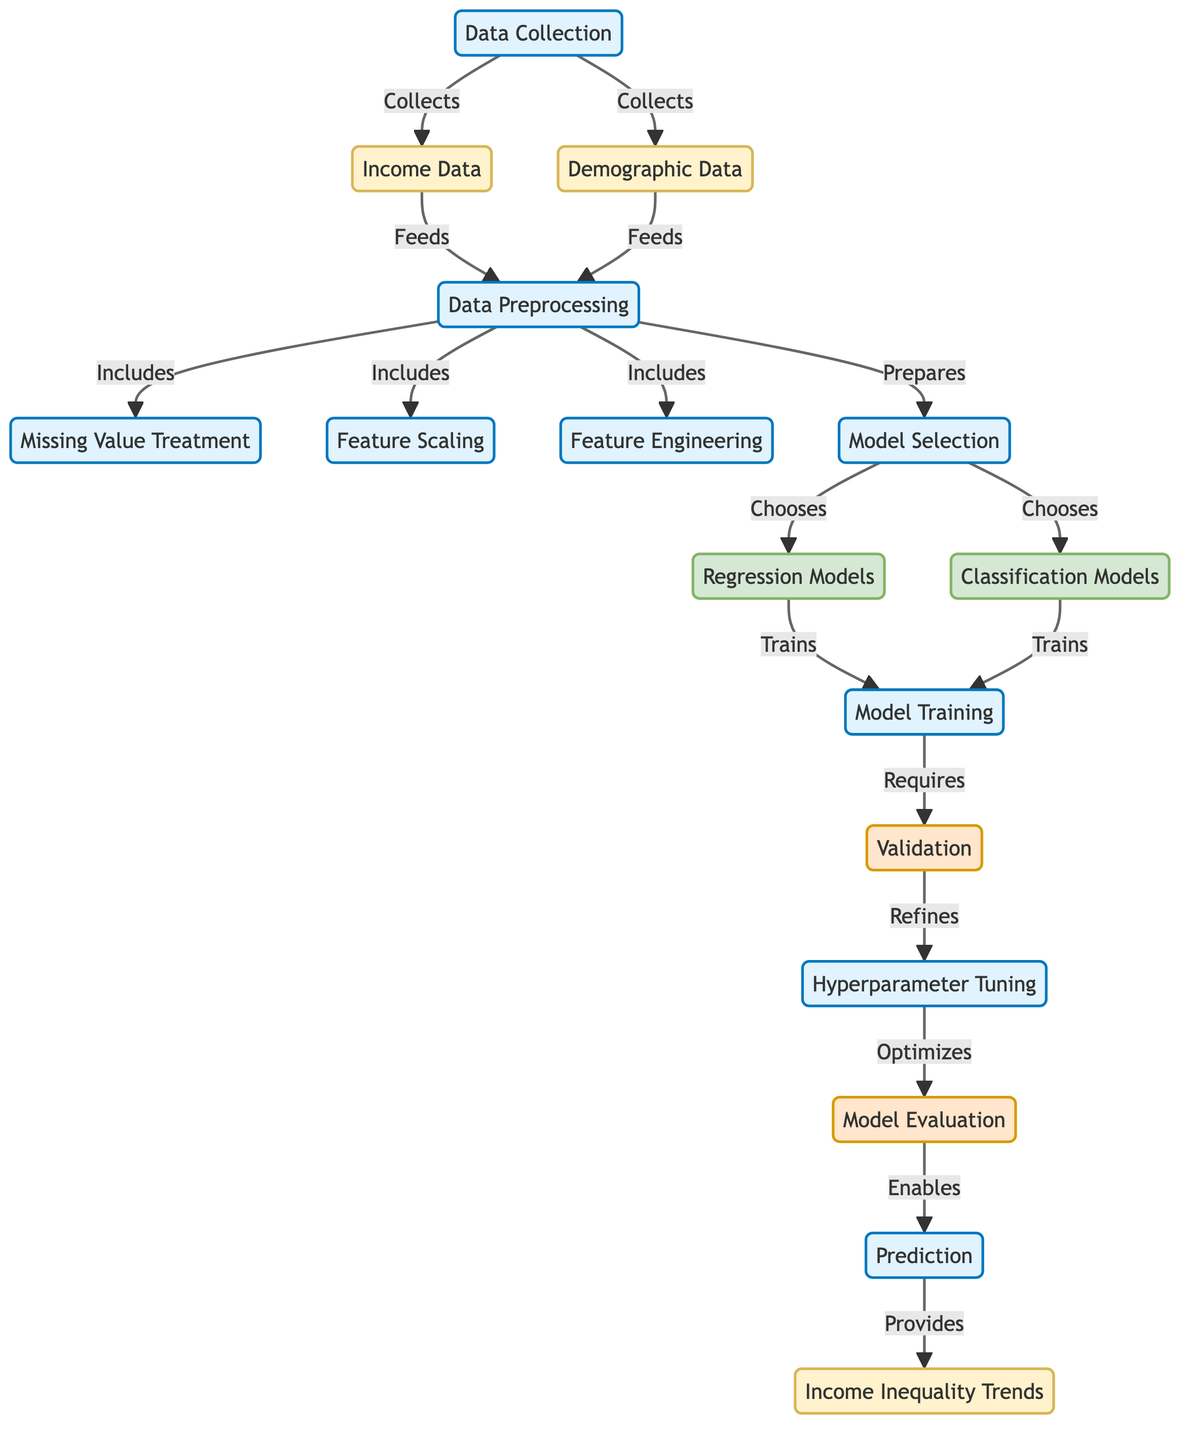What nodes are involved in data collection? The diagram indicates that two nodes are involved in data collection: Income Data and Demographic Data, both of which are collected during the Data Collection process.
Answer: Income Data, Demographic Data What processes come after data preprocessing? After the Data Preprocessing step, the next processes in the flow are Model Selection, indicating that the preprocessed data is essential for choosing appropriate models for training.
Answer: Model Selection How many types of models are selected during model selection? The diagram shows that there are two types of models selected during the Model Selection step: Regression Models and Classification Models.
Answer: Two What does model evaluation enable? The diagram states that Model Evaluation enables the Prediction step, indicating that evaluating the model is critical for making predictions about income inequality trends.
Answer: Prediction Which node requires validation during the training phase? The diagram highlights that the Training process requires Validation, indicating that validation is an important part of ensuring the quality of the training step.
Answer: Validation What is the final output of this diagram? The final output, as indicated in the diagram, is the Income Inequality Trends, which are derived from the Prediction step.
Answer: Income Inequality Trends What is the first process in the flowchart? The first process in the flowchart is Data Collection, highlighting the initial step of gathering relevant income and demographic data for analysis.
Answer: Data Collection Which process includes missing value treatment? The diagram shows that Missing Value Treatment is included in the Data Preprocessing step, as part of preparing the data for further analysis.
Answer: Data Preprocessing How does hyperparameter tuning affect model evaluation? According to the diagram, Hyperparameter Tuning optimizes Model Evaluation, suggesting that tuning the model parameters helps improve its evaluation metrics.
Answer: Optimizes 